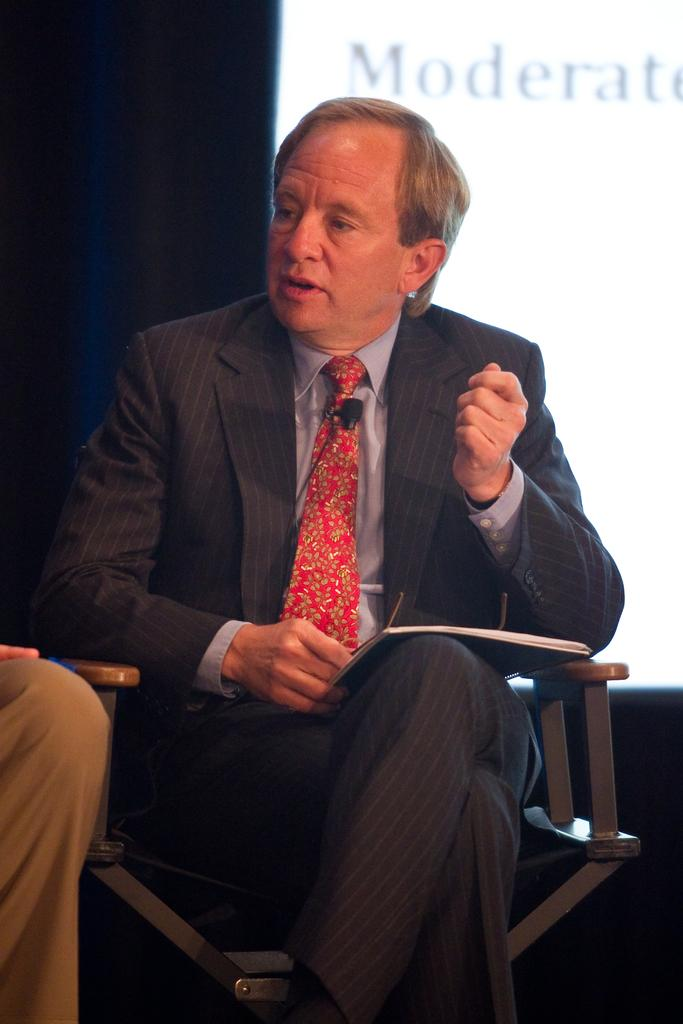What is the person in the image wearing? The person is wearing a suit in the image. What is the person doing with the book? The person is holding a book on his lap. What is the person sitting on? The person is sitting on a chair. What is the person doing while sitting on the chair? The person is speaking. What can be seen in the background of the image? There is a screen in the background of the image, and the background is dark in color. Is the person wearing a scarf in the image? There is no mention of a scarf in the image, so it cannot be determined if the person is wearing one. Can you tell me how many family members are present in the image? There is no mention of family members in the image, so it cannot be determined. 